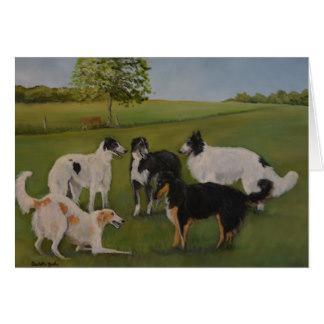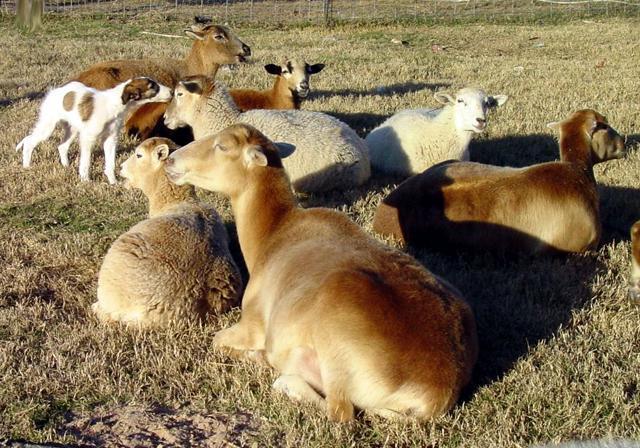The first image is the image on the left, the second image is the image on the right. Assess this claim about the two images: "An image shows hounds standing on grass with a toy in the scene.". Correct or not? Answer yes or no. No. 